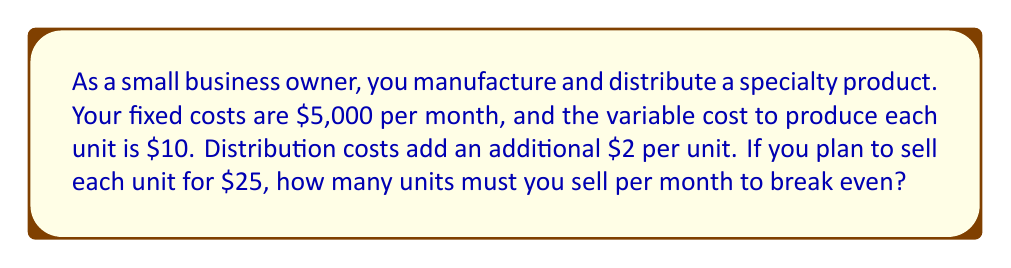Provide a solution to this math problem. Let's approach this step-by-step:

1) First, let's define our variables:
   $x$ = number of units sold
   $P$ = price per unit
   $V$ = variable cost per unit
   $D$ = distribution cost per unit
   $F$ = fixed costs

2) We know:
   $P = $25
   $V = $10
   $D = $2
   $F = $5,000

3) The break-even point occurs when total revenue equals total costs:
   $\text{Total Revenue} = \text{Total Costs}$

4) We can express this as an equation:
   $Px = F + (V+D)x$

5) Substituting our known values:
   $25x = 5000 + (10+2)x$
   $25x = 5000 + 12x$

6) Solve for $x$:
   $25x - 12x = 5000$
   $13x = 5000$
   $x = \frac{5000}{13} \approx 384.62$

7) Since we can't sell a fraction of a unit, we round up to the nearest whole number.
Answer: 385 units 